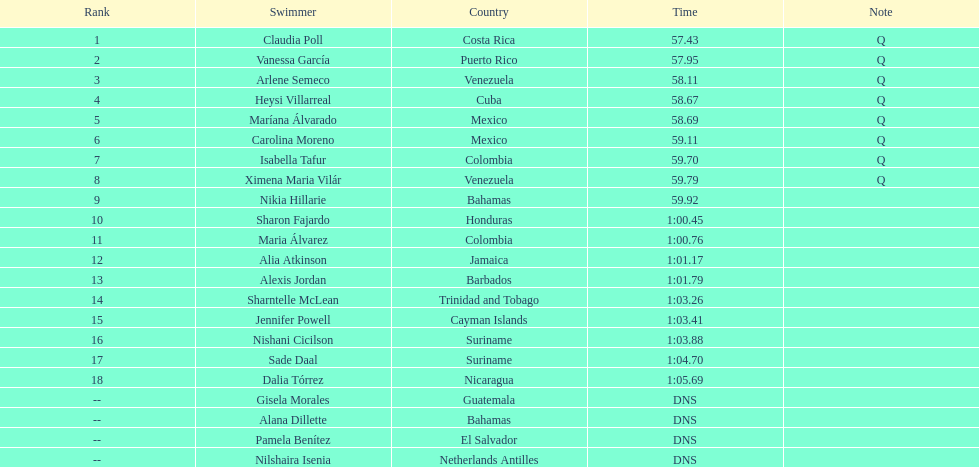What is the number of mexican swimmers who are ranked in the top 10? 2. 